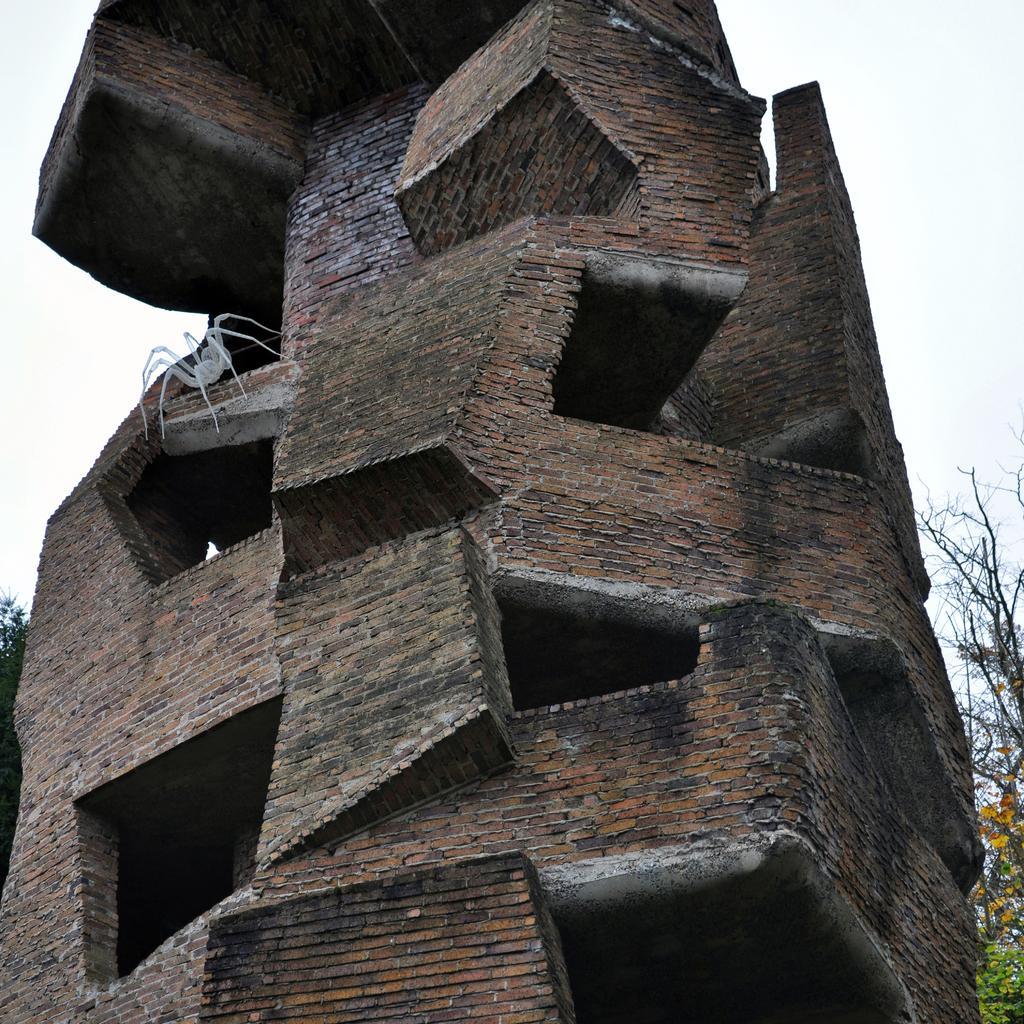How would you summarize this image in a sentence or two? In this picture I can see a building, there is a spider, there are trees, and in the background there is the sky. 